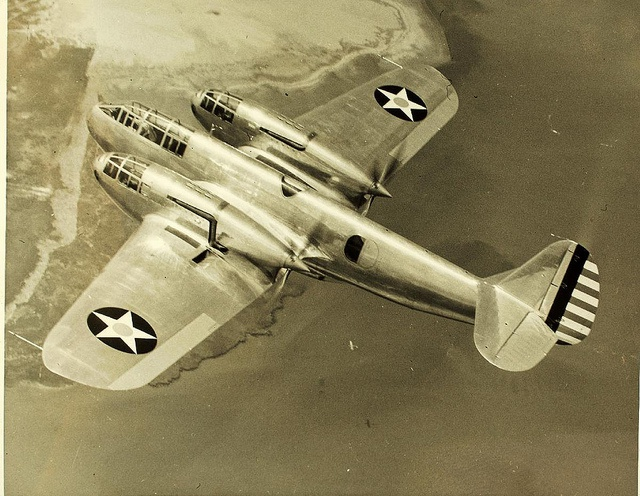Describe the objects in this image and their specific colors. I can see a airplane in beige, tan, and black tones in this image. 